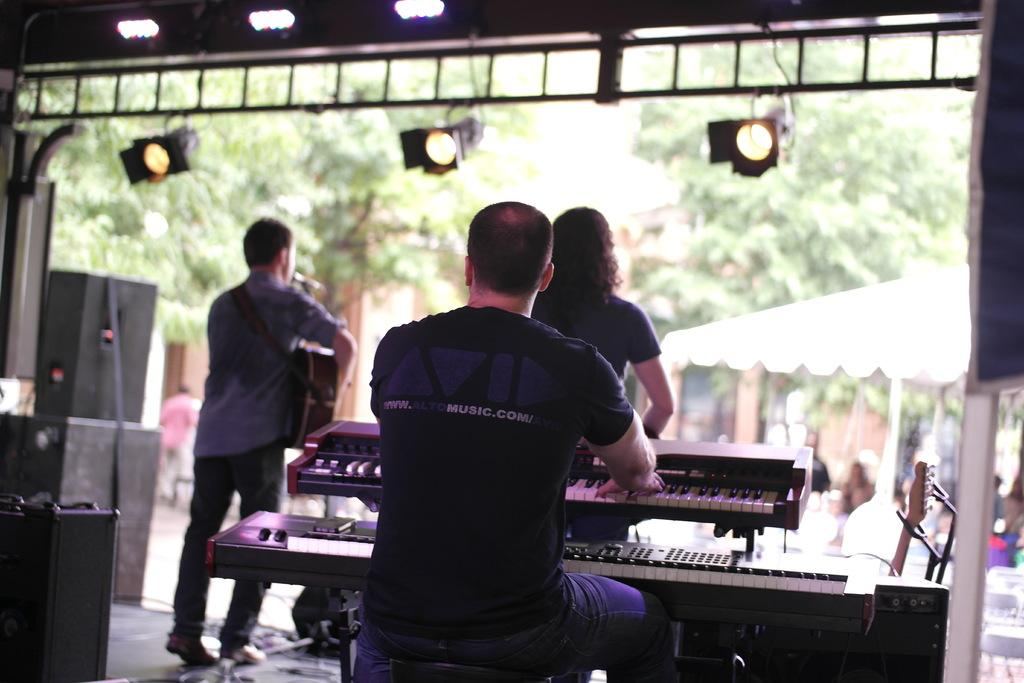How many people are on the stage in the image? There are three people on the stage in the image. What are the people on the stage doing? One person is playing the piano, and another person is holding a guitar. What can be seen in the background of the image? There are trees visible in the background. What type of land is visible in the image? There is no specific type of land visible in the image; only trees are mentioned in the background. Is there a hospital present in the image? No, there is no hospital present in the image. 